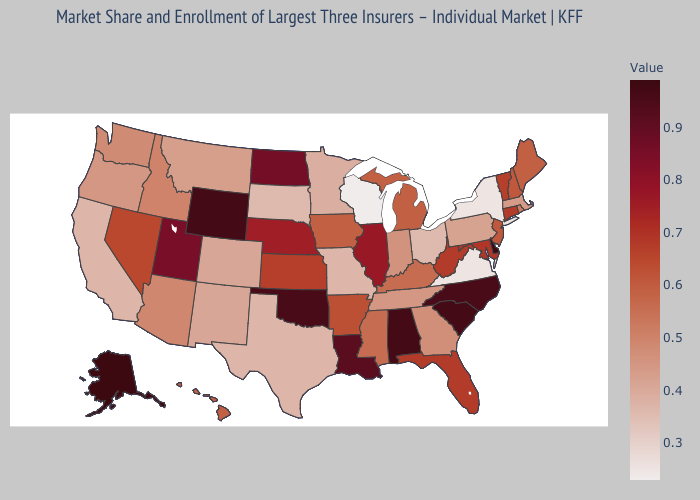Does New Mexico have a lower value than New York?
Answer briefly. No. Does Connecticut have the highest value in the Northeast?
Concise answer only. Yes. Among the states that border Kansas , which have the lowest value?
Concise answer only. Missouri. 